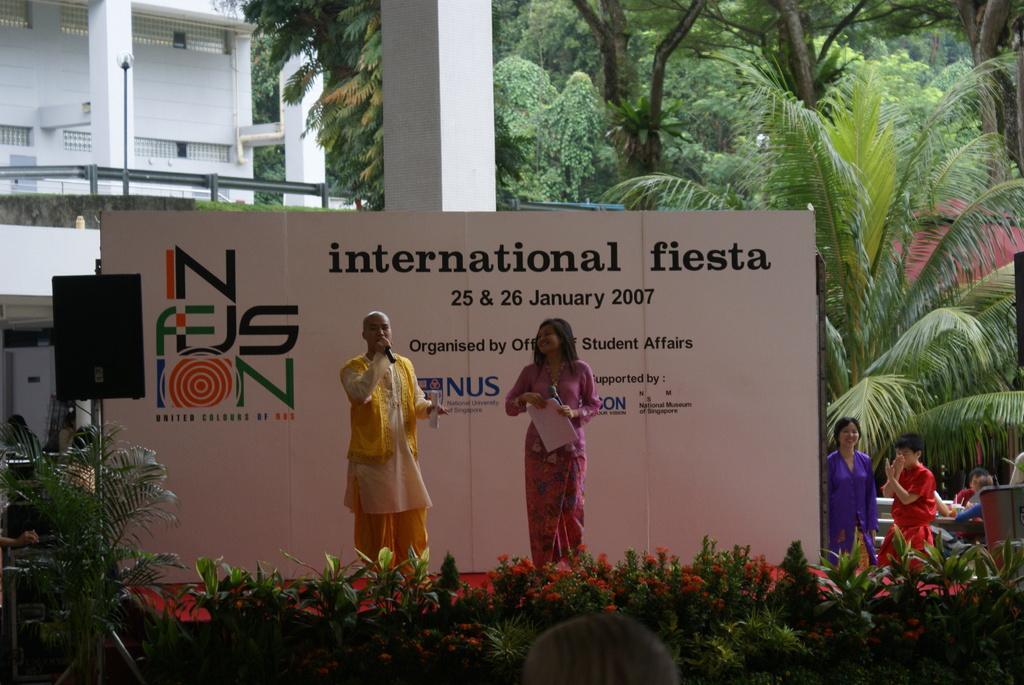In one or two sentences, can you explain what this image depicts? In this picture we can see some plants and flowers at the bottom, there are four persons, a hoarding and a speaker in the middle, in the background there are some trees and a building, two persons in the middle are holding microphones and papers. 